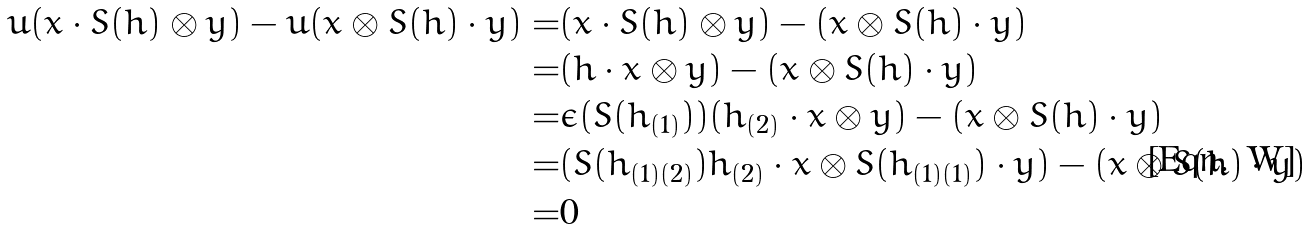Convert formula to latex. <formula><loc_0><loc_0><loc_500><loc_500>u ( x \cdot S ( h ) \otimes y ) - u ( x \otimes S ( h ) \cdot y ) = & ( x \cdot S ( h ) \otimes y ) - ( x \otimes S ( h ) \cdot y ) \\ = & ( h \cdot x \otimes y ) - ( x \otimes S ( h ) \cdot y ) \\ = & \epsilon ( S ( h _ { ( 1 ) } ) ) ( h _ { ( 2 ) } \cdot x \otimes y ) - ( x \otimes S ( h ) \cdot y ) \\ = & ( S ( h _ { ( 1 ) ( 2 ) } ) h _ { ( 2 ) } \cdot x \otimes S ( h _ { ( 1 ) ( 1 ) } ) \cdot y ) - ( x \otimes S ( h ) \cdot y ) \\ = & 0</formula> 